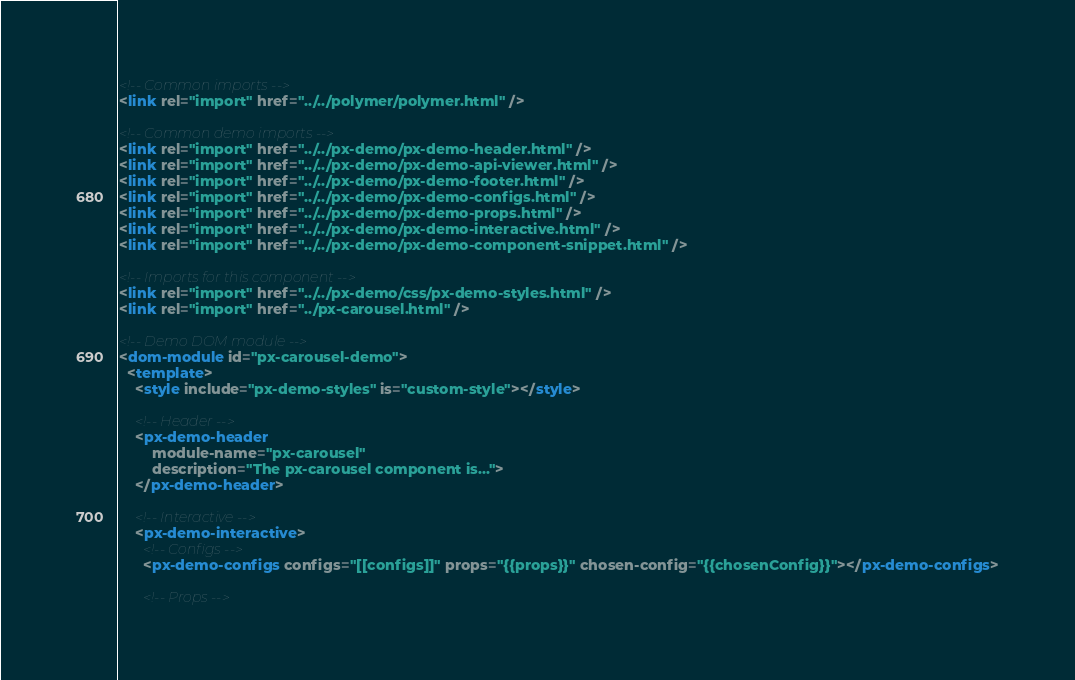Convert code to text. <code><loc_0><loc_0><loc_500><loc_500><_HTML_><!-- Common imports -->
<link rel="import" href="../../polymer/polymer.html" />

<!-- Common demo imports -->
<link rel="import" href="../../px-demo/px-demo-header.html" />
<link rel="import" href="../../px-demo/px-demo-api-viewer.html" />
<link rel="import" href="../../px-demo/px-demo-footer.html" />
<link rel="import" href="../../px-demo/px-demo-configs.html" />
<link rel="import" href="../../px-demo/px-demo-props.html" />
<link rel="import" href="../../px-demo/px-demo-interactive.html" />
<link rel="import" href="../../px-demo/px-demo-component-snippet.html" />

<!-- Imports for this component -->
<link rel="import" href="../../px-demo/css/px-demo-styles.html" />
<link rel="import" href="../px-carousel.html" />

<!-- Demo DOM module -->
<dom-module id="px-carousel-demo">
  <template>
    <style include="px-demo-styles" is="custom-style"></style>

    <!-- Header -->
    <px-demo-header
        module-name="px-carousel"
        description="The px-carousel component is...">
    </px-demo-header>

    <!-- Interactive -->
    <px-demo-interactive>
      <!-- Configs -->
      <px-demo-configs configs="[[configs]]" props="{{props}}" chosen-config="{{chosenConfig}}"></px-demo-configs>

      <!-- Props --></code> 